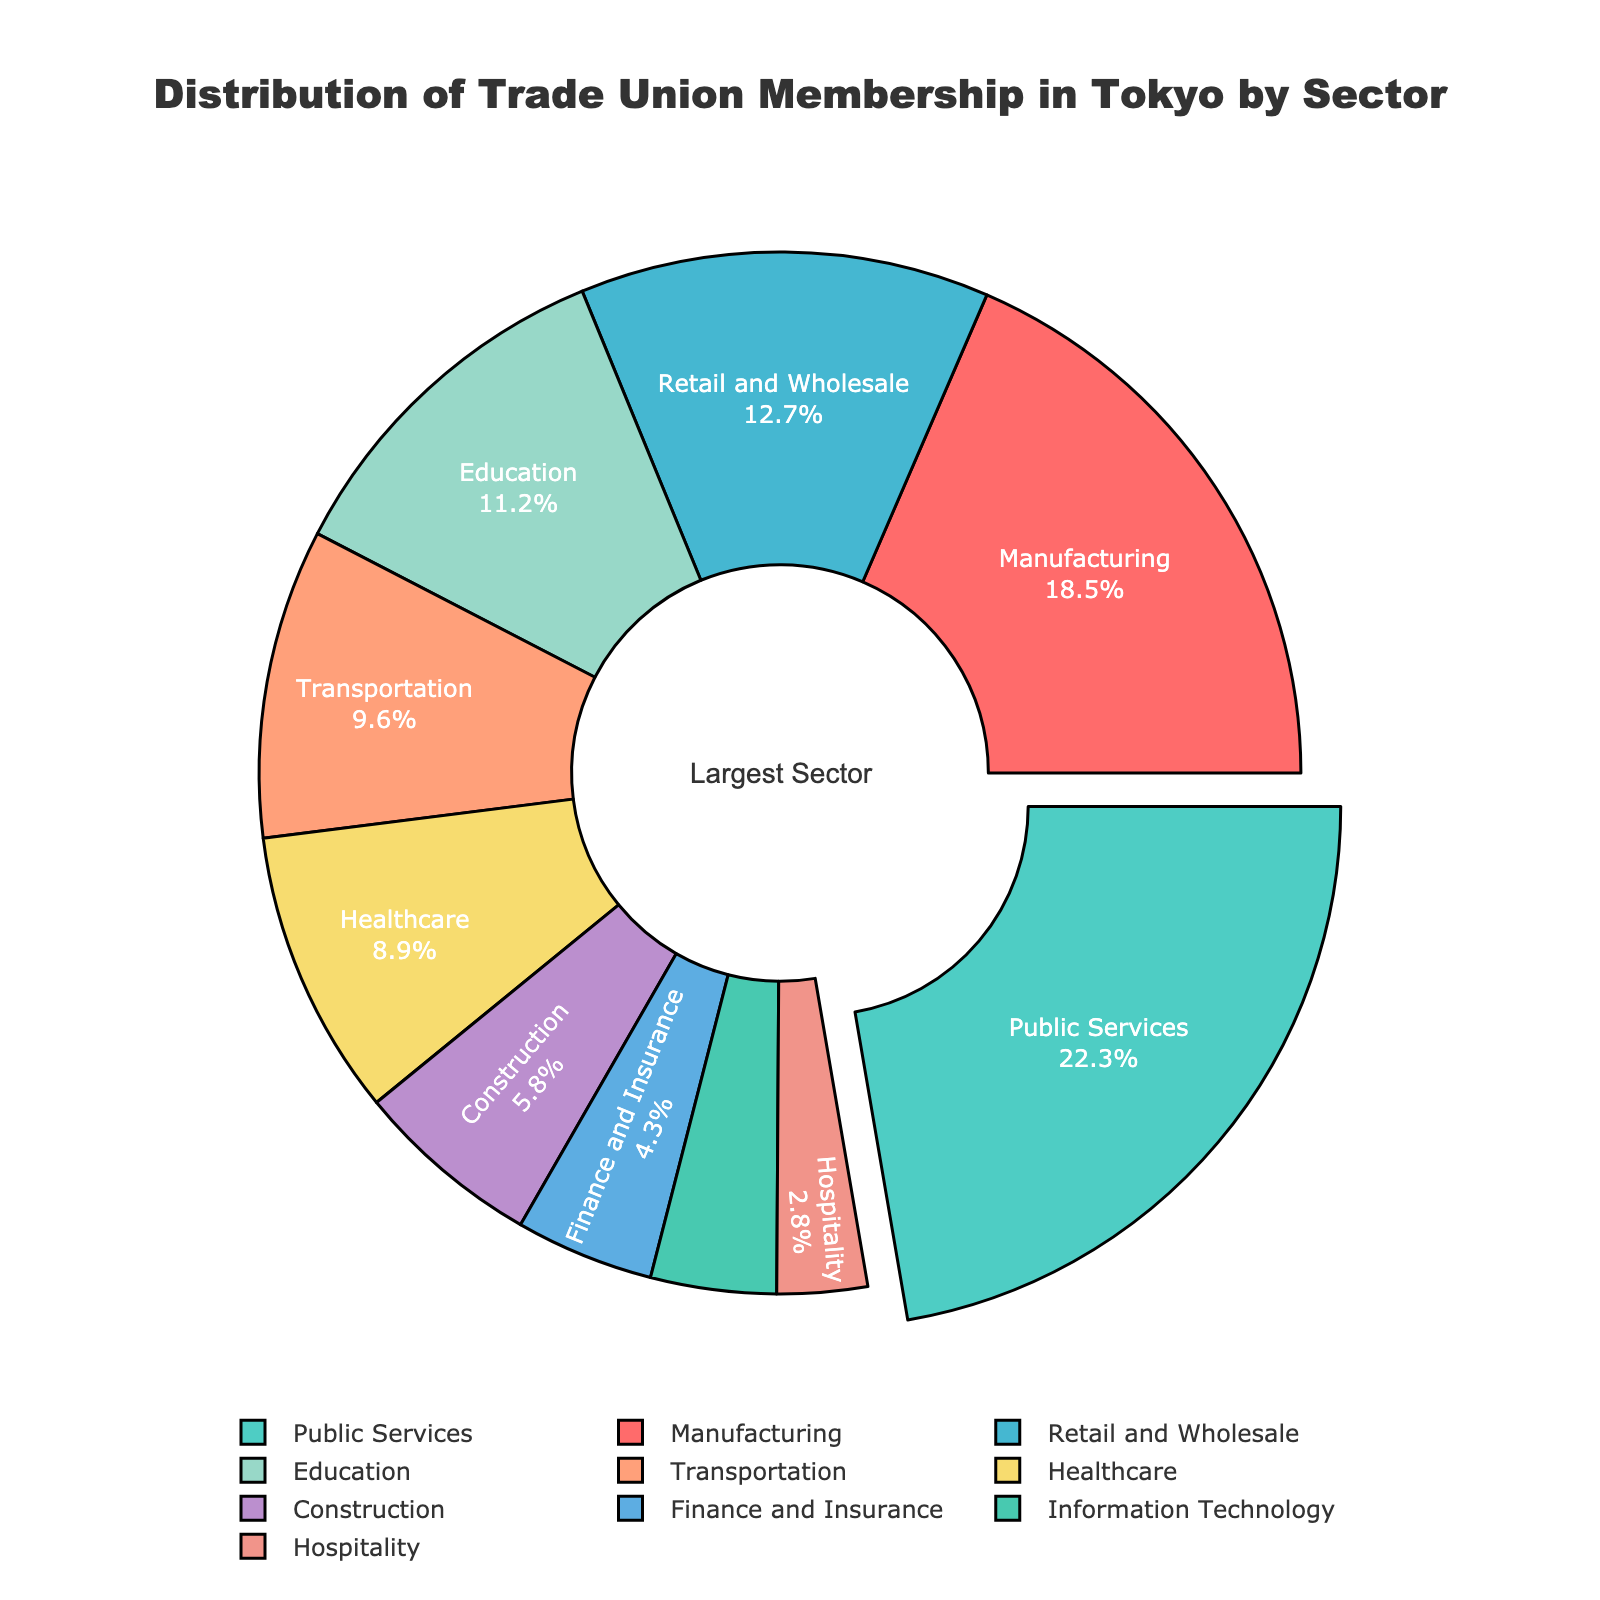What's the sector with the largest trade union membership percentage? The sector with the largest trade union membership percentage is indicated by the largest slice of the pie chart, which is also pulled out slightly more than others. In this case, it is "Public Services" with a percentage of 22.3%.
Answer: Public Services How much larger is the percentage of trade union membership in Public Services compared to Healthcare? The percentage of trade union membership in Public Services is 22.3%, and for Healthcare, it is 8.9%. The difference between these percentages is calculated by subtracting 8.9% from 22.3%, which equals 13.4%.
Answer: 13.4% Which sectors have less than 5% of trade union membership, and what are their percentages combined? The sectors with less than 5% of trade union membership are Finance and Insurance (4.3%) and Information Technology (3.9%). Adding these two percentages together, we get 4.3 + 3.9 = 8.2%.
Answer: Finance and Insurance, Information Technology, 8.2% Is the trade union membership percentage in Manufacturing greater than that in Education? From the pie chart, the percentage for Manufacturing is 18.5%, and for Education, it is 11.2%. Comparing these two values, 18.5% is indeed greater than 11.2%.
Answer: Yes What is the combined percentage of trade union membership in the top three sectors? The top three sectors by percentage are Public Services (22.3%), Manufacturing (18.5%), and Retail and Wholesale (12.7%). Adding these percentages together, we get 22.3 + 18.5 + 12.7 = 53.5%.
Answer: 53.5% Which sector is represented by the green color on the pie chart? The pie chart uses different colors for each sector. The sector represented by the green color is "Public Services."
Answer: Public Services How does the trade union membership in Education compare to that in Transportation? The percentage for Education is 11.2%, and for Transportation, it is 9.6%. This means the trade union membership in Education is higher than that in Transportation by 1.6%.
Answer: Education is higher by 1.6% Which sectors have a trade union membership percentage closest to 10%? The sectors with trade union membership percentages close to 10% are Transportation (9.6%) and Education (11.2%). These are the values closest to 10%.
Answer: Transportation, Education What's the sum of trade union membership percentages for Healthcare, Construction, and Hospitality? The percentages for Healthcare, Construction, and Hospitality are 8.9%, 5.8%, and 2.8% respectively. Adding these together, we get 8.9 + 5.8 + 2.8 = 17.5%.
Answer: 17.5% What is the smallest sector by trade union membership percentage, and what color represents it? The smallest sector by trade union membership percentage is Hospitality, at 2.8%. The color used to represent Hospitality is light pink.
Answer: Hospitality, light pink 